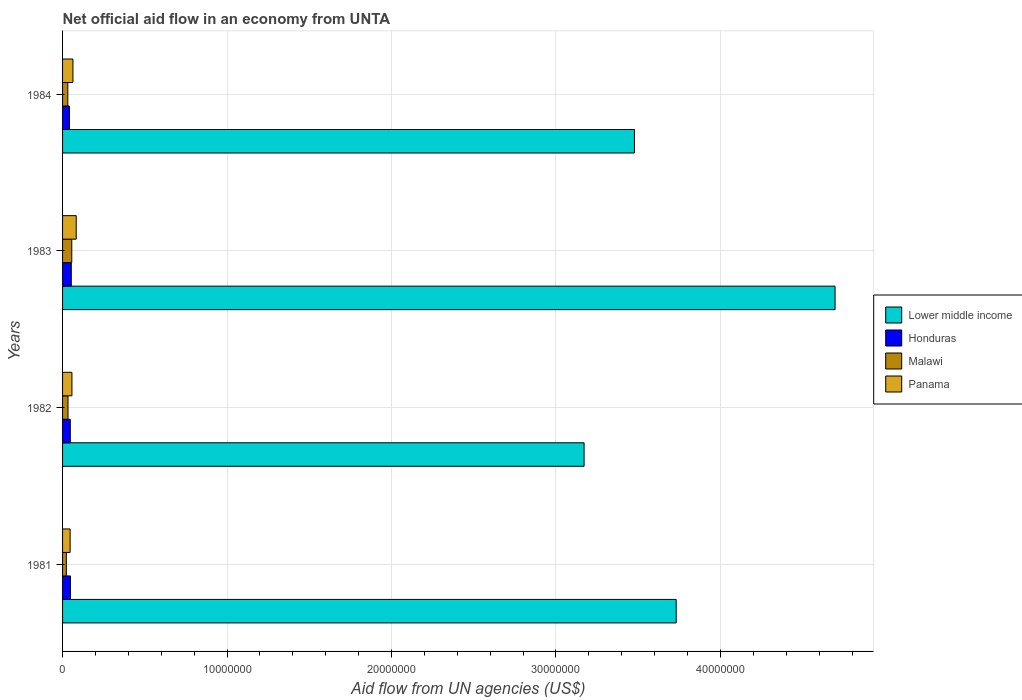How many different coloured bars are there?
Your answer should be compact. 4. Are the number of bars per tick equal to the number of legend labels?
Offer a very short reply. Yes. Are the number of bars on each tick of the Y-axis equal?
Offer a terse response. Yes. Across all years, what is the maximum net official aid flow in Honduras?
Offer a terse response. 5.30e+05. Across all years, what is the minimum net official aid flow in Malawi?
Provide a short and direct response. 2.30e+05. In which year was the net official aid flow in Honduras minimum?
Your answer should be very brief. 1984. What is the total net official aid flow in Honduras in the graph?
Offer a very short reply. 1.90e+06. What is the difference between the net official aid flow in Lower middle income in 1983 and that in 1984?
Keep it short and to the point. 1.22e+07. What is the average net official aid flow in Lower middle income per year?
Make the answer very short. 3.77e+07. In the year 1983, what is the difference between the net official aid flow in Honduras and net official aid flow in Malawi?
Ensure brevity in your answer.  -3.00e+04. What is the ratio of the net official aid flow in Panama in 1982 to that in 1984?
Your answer should be very brief. 0.9. Is the difference between the net official aid flow in Honduras in 1983 and 1984 greater than the difference between the net official aid flow in Malawi in 1983 and 1984?
Give a very brief answer. No. What is the difference between the highest and the second highest net official aid flow in Lower middle income?
Make the answer very short. 9.66e+06. What is the difference between the highest and the lowest net official aid flow in Lower middle income?
Provide a short and direct response. 1.53e+07. In how many years, is the net official aid flow in Honduras greater than the average net official aid flow in Honduras taken over all years?
Your answer should be very brief. 2. Is the sum of the net official aid flow in Lower middle income in 1982 and 1983 greater than the maximum net official aid flow in Malawi across all years?
Offer a very short reply. Yes. What does the 2nd bar from the top in 1983 represents?
Keep it short and to the point. Malawi. What does the 1st bar from the bottom in 1984 represents?
Provide a short and direct response. Lower middle income. Is it the case that in every year, the sum of the net official aid flow in Lower middle income and net official aid flow in Honduras is greater than the net official aid flow in Malawi?
Your answer should be compact. Yes. How many years are there in the graph?
Offer a very short reply. 4. What is the difference between two consecutive major ticks on the X-axis?
Provide a succinct answer. 1.00e+07. Are the values on the major ticks of X-axis written in scientific E-notation?
Ensure brevity in your answer.  No. Where does the legend appear in the graph?
Provide a short and direct response. Center right. How are the legend labels stacked?
Ensure brevity in your answer.  Vertical. What is the title of the graph?
Make the answer very short. Net official aid flow in an economy from UNTA. Does "Switzerland" appear as one of the legend labels in the graph?
Your response must be concise. No. What is the label or title of the X-axis?
Your response must be concise. Aid flow from UN agencies (US$). What is the Aid flow from UN agencies (US$) of Lower middle income in 1981?
Give a very brief answer. 3.73e+07. What is the Aid flow from UN agencies (US$) of Panama in 1981?
Provide a succinct answer. 4.60e+05. What is the Aid flow from UN agencies (US$) in Lower middle income in 1982?
Provide a succinct answer. 3.17e+07. What is the Aid flow from UN agencies (US$) of Honduras in 1982?
Provide a succinct answer. 4.70e+05. What is the Aid flow from UN agencies (US$) in Malawi in 1982?
Offer a very short reply. 3.30e+05. What is the Aid flow from UN agencies (US$) in Panama in 1982?
Make the answer very short. 5.70e+05. What is the Aid flow from UN agencies (US$) of Lower middle income in 1983?
Give a very brief answer. 4.70e+07. What is the Aid flow from UN agencies (US$) of Honduras in 1983?
Give a very brief answer. 5.30e+05. What is the Aid flow from UN agencies (US$) of Malawi in 1983?
Ensure brevity in your answer.  5.60e+05. What is the Aid flow from UN agencies (US$) of Panama in 1983?
Your answer should be very brief. 8.30e+05. What is the Aid flow from UN agencies (US$) in Lower middle income in 1984?
Make the answer very short. 3.48e+07. What is the Aid flow from UN agencies (US$) in Honduras in 1984?
Your answer should be compact. 4.20e+05. What is the Aid flow from UN agencies (US$) of Panama in 1984?
Make the answer very short. 6.30e+05. Across all years, what is the maximum Aid flow from UN agencies (US$) of Lower middle income?
Your answer should be compact. 4.70e+07. Across all years, what is the maximum Aid flow from UN agencies (US$) of Honduras?
Offer a terse response. 5.30e+05. Across all years, what is the maximum Aid flow from UN agencies (US$) of Malawi?
Your answer should be very brief. 5.60e+05. Across all years, what is the maximum Aid flow from UN agencies (US$) of Panama?
Your answer should be compact. 8.30e+05. Across all years, what is the minimum Aid flow from UN agencies (US$) in Lower middle income?
Provide a succinct answer. 3.17e+07. Across all years, what is the minimum Aid flow from UN agencies (US$) in Honduras?
Provide a short and direct response. 4.20e+05. Across all years, what is the minimum Aid flow from UN agencies (US$) in Malawi?
Ensure brevity in your answer.  2.30e+05. What is the total Aid flow from UN agencies (US$) in Lower middle income in the graph?
Ensure brevity in your answer.  1.51e+08. What is the total Aid flow from UN agencies (US$) of Honduras in the graph?
Give a very brief answer. 1.90e+06. What is the total Aid flow from UN agencies (US$) of Malawi in the graph?
Provide a short and direct response. 1.44e+06. What is the total Aid flow from UN agencies (US$) of Panama in the graph?
Give a very brief answer. 2.49e+06. What is the difference between the Aid flow from UN agencies (US$) in Lower middle income in 1981 and that in 1982?
Offer a very short reply. 5.60e+06. What is the difference between the Aid flow from UN agencies (US$) in Honduras in 1981 and that in 1982?
Offer a very short reply. 10000. What is the difference between the Aid flow from UN agencies (US$) in Lower middle income in 1981 and that in 1983?
Keep it short and to the point. -9.66e+06. What is the difference between the Aid flow from UN agencies (US$) in Honduras in 1981 and that in 1983?
Your answer should be compact. -5.00e+04. What is the difference between the Aid flow from UN agencies (US$) in Malawi in 1981 and that in 1983?
Your answer should be very brief. -3.30e+05. What is the difference between the Aid flow from UN agencies (US$) in Panama in 1981 and that in 1983?
Keep it short and to the point. -3.70e+05. What is the difference between the Aid flow from UN agencies (US$) in Lower middle income in 1981 and that in 1984?
Your response must be concise. 2.54e+06. What is the difference between the Aid flow from UN agencies (US$) of Honduras in 1981 and that in 1984?
Your answer should be compact. 6.00e+04. What is the difference between the Aid flow from UN agencies (US$) in Panama in 1981 and that in 1984?
Your answer should be compact. -1.70e+05. What is the difference between the Aid flow from UN agencies (US$) of Lower middle income in 1982 and that in 1983?
Your response must be concise. -1.53e+07. What is the difference between the Aid flow from UN agencies (US$) in Honduras in 1982 and that in 1983?
Provide a short and direct response. -6.00e+04. What is the difference between the Aid flow from UN agencies (US$) in Lower middle income in 1982 and that in 1984?
Your response must be concise. -3.06e+06. What is the difference between the Aid flow from UN agencies (US$) in Lower middle income in 1983 and that in 1984?
Your answer should be very brief. 1.22e+07. What is the difference between the Aid flow from UN agencies (US$) of Honduras in 1983 and that in 1984?
Provide a short and direct response. 1.10e+05. What is the difference between the Aid flow from UN agencies (US$) of Malawi in 1983 and that in 1984?
Give a very brief answer. 2.40e+05. What is the difference between the Aid flow from UN agencies (US$) of Panama in 1983 and that in 1984?
Your answer should be compact. 2.00e+05. What is the difference between the Aid flow from UN agencies (US$) in Lower middle income in 1981 and the Aid flow from UN agencies (US$) in Honduras in 1982?
Offer a very short reply. 3.68e+07. What is the difference between the Aid flow from UN agencies (US$) of Lower middle income in 1981 and the Aid flow from UN agencies (US$) of Malawi in 1982?
Your answer should be very brief. 3.70e+07. What is the difference between the Aid flow from UN agencies (US$) in Lower middle income in 1981 and the Aid flow from UN agencies (US$) in Panama in 1982?
Offer a terse response. 3.67e+07. What is the difference between the Aid flow from UN agencies (US$) of Lower middle income in 1981 and the Aid flow from UN agencies (US$) of Honduras in 1983?
Your answer should be very brief. 3.68e+07. What is the difference between the Aid flow from UN agencies (US$) in Lower middle income in 1981 and the Aid flow from UN agencies (US$) in Malawi in 1983?
Provide a short and direct response. 3.68e+07. What is the difference between the Aid flow from UN agencies (US$) of Lower middle income in 1981 and the Aid flow from UN agencies (US$) of Panama in 1983?
Give a very brief answer. 3.65e+07. What is the difference between the Aid flow from UN agencies (US$) of Honduras in 1981 and the Aid flow from UN agencies (US$) of Panama in 1983?
Give a very brief answer. -3.50e+05. What is the difference between the Aid flow from UN agencies (US$) of Malawi in 1981 and the Aid flow from UN agencies (US$) of Panama in 1983?
Provide a short and direct response. -6.00e+05. What is the difference between the Aid flow from UN agencies (US$) in Lower middle income in 1981 and the Aid flow from UN agencies (US$) in Honduras in 1984?
Provide a short and direct response. 3.69e+07. What is the difference between the Aid flow from UN agencies (US$) in Lower middle income in 1981 and the Aid flow from UN agencies (US$) in Malawi in 1984?
Your answer should be very brief. 3.70e+07. What is the difference between the Aid flow from UN agencies (US$) in Lower middle income in 1981 and the Aid flow from UN agencies (US$) in Panama in 1984?
Keep it short and to the point. 3.67e+07. What is the difference between the Aid flow from UN agencies (US$) in Honduras in 1981 and the Aid flow from UN agencies (US$) in Panama in 1984?
Offer a very short reply. -1.50e+05. What is the difference between the Aid flow from UN agencies (US$) of Malawi in 1981 and the Aid flow from UN agencies (US$) of Panama in 1984?
Keep it short and to the point. -4.00e+05. What is the difference between the Aid flow from UN agencies (US$) in Lower middle income in 1982 and the Aid flow from UN agencies (US$) in Honduras in 1983?
Your answer should be very brief. 3.12e+07. What is the difference between the Aid flow from UN agencies (US$) in Lower middle income in 1982 and the Aid flow from UN agencies (US$) in Malawi in 1983?
Offer a terse response. 3.12e+07. What is the difference between the Aid flow from UN agencies (US$) of Lower middle income in 1982 and the Aid flow from UN agencies (US$) of Panama in 1983?
Ensure brevity in your answer.  3.09e+07. What is the difference between the Aid flow from UN agencies (US$) in Honduras in 1982 and the Aid flow from UN agencies (US$) in Panama in 1983?
Offer a terse response. -3.60e+05. What is the difference between the Aid flow from UN agencies (US$) in Malawi in 1982 and the Aid flow from UN agencies (US$) in Panama in 1983?
Offer a terse response. -5.00e+05. What is the difference between the Aid flow from UN agencies (US$) of Lower middle income in 1982 and the Aid flow from UN agencies (US$) of Honduras in 1984?
Your answer should be very brief. 3.13e+07. What is the difference between the Aid flow from UN agencies (US$) in Lower middle income in 1982 and the Aid flow from UN agencies (US$) in Malawi in 1984?
Keep it short and to the point. 3.14e+07. What is the difference between the Aid flow from UN agencies (US$) in Lower middle income in 1982 and the Aid flow from UN agencies (US$) in Panama in 1984?
Provide a succinct answer. 3.11e+07. What is the difference between the Aid flow from UN agencies (US$) in Malawi in 1982 and the Aid flow from UN agencies (US$) in Panama in 1984?
Your response must be concise. -3.00e+05. What is the difference between the Aid flow from UN agencies (US$) of Lower middle income in 1983 and the Aid flow from UN agencies (US$) of Honduras in 1984?
Keep it short and to the point. 4.66e+07. What is the difference between the Aid flow from UN agencies (US$) of Lower middle income in 1983 and the Aid flow from UN agencies (US$) of Malawi in 1984?
Offer a terse response. 4.66e+07. What is the difference between the Aid flow from UN agencies (US$) in Lower middle income in 1983 and the Aid flow from UN agencies (US$) in Panama in 1984?
Your response must be concise. 4.63e+07. What is the difference between the Aid flow from UN agencies (US$) in Honduras in 1983 and the Aid flow from UN agencies (US$) in Malawi in 1984?
Your answer should be compact. 2.10e+05. What is the average Aid flow from UN agencies (US$) of Lower middle income per year?
Give a very brief answer. 3.77e+07. What is the average Aid flow from UN agencies (US$) of Honduras per year?
Your response must be concise. 4.75e+05. What is the average Aid flow from UN agencies (US$) of Malawi per year?
Your response must be concise. 3.60e+05. What is the average Aid flow from UN agencies (US$) in Panama per year?
Your answer should be very brief. 6.22e+05. In the year 1981, what is the difference between the Aid flow from UN agencies (US$) in Lower middle income and Aid flow from UN agencies (US$) in Honduras?
Give a very brief answer. 3.68e+07. In the year 1981, what is the difference between the Aid flow from UN agencies (US$) in Lower middle income and Aid flow from UN agencies (US$) in Malawi?
Ensure brevity in your answer.  3.71e+07. In the year 1981, what is the difference between the Aid flow from UN agencies (US$) in Lower middle income and Aid flow from UN agencies (US$) in Panama?
Provide a short and direct response. 3.68e+07. In the year 1981, what is the difference between the Aid flow from UN agencies (US$) in Honduras and Aid flow from UN agencies (US$) in Malawi?
Your response must be concise. 2.50e+05. In the year 1981, what is the difference between the Aid flow from UN agencies (US$) of Honduras and Aid flow from UN agencies (US$) of Panama?
Ensure brevity in your answer.  2.00e+04. In the year 1982, what is the difference between the Aid flow from UN agencies (US$) in Lower middle income and Aid flow from UN agencies (US$) in Honduras?
Keep it short and to the point. 3.12e+07. In the year 1982, what is the difference between the Aid flow from UN agencies (US$) of Lower middle income and Aid flow from UN agencies (US$) of Malawi?
Make the answer very short. 3.14e+07. In the year 1982, what is the difference between the Aid flow from UN agencies (US$) of Lower middle income and Aid flow from UN agencies (US$) of Panama?
Your answer should be compact. 3.11e+07. In the year 1982, what is the difference between the Aid flow from UN agencies (US$) of Honduras and Aid flow from UN agencies (US$) of Malawi?
Keep it short and to the point. 1.40e+05. In the year 1982, what is the difference between the Aid flow from UN agencies (US$) of Honduras and Aid flow from UN agencies (US$) of Panama?
Your answer should be very brief. -1.00e+05. In the year 1983, what is the difference between the Aid flow from UN agencies (US$) of Lower middle income and Aid flow from UN agencies (US$) of Honduras?
Keep it short and to the point. 4.64e+07. In the year 1983, what is the difference between the Aid flow from UN agencies (US$) in Lower middle income and Aid flow from UN agencies (US$) in Malawi?
Offer a terse response. 4.64e+07. In the year 1983, what is the difference between the Aid flow from UN agencies (US$) of Lower middle income and Aid flow from UN agencies (US$) of Panama?
Offer a very short reply. 4.61e+07. In the year 1983, what is the difference between the Aid flow from UN agencies (US$) of Honduras and Aid flow from UN agencies (US$) of Malawi?
Your response must be concise. -3.00e+04. In the year 1984, what is the difference between the Aid flow from UN agencies (US$) in Lower middle income and Aid flow from UN agencies (US$) in Honduras?
Offer a terse response. 3.44e+07. In the year 1984, what is the difference between the Aid flow from UN agencies (US$) in Lower middle income and Aid flow from UN agencies (US$) in Malawi?
Provide a succinct answer. 3.44e+07. In the year 1984, what is the difference between the Aid flow from UN agencies (US$) in Lower middle income and Aid flow from UN agencies (US$) in Panama?
Your answer should be very brief. 3.41e+07. In the year 1984, what is the difference between the Aid flow from UN agencies (US$) of Honduras and Aid flow from UN agencies (US$) of Malawi?
Your response must be concise. 1.00e+05. In the year 1984, what is the difference between the Aid flow from UN agencies (US$) of Honduras and Aid flow from UN agencies (US$) of Panama?
Your response must be concise. -2.10e+05. In the year 1984, what is the difference between the Aid flow from UN agencies (US$) in Malawi and Aid flow from UN agencies (US$) in Panama?
Your answer should be very brief. -3.10e+05. What is the ratio of the Aid flow from UN agencies (US$) in Lower middle income in 1981 to that in 1982?
Provide a short and direct response. 1.18. What is the ratio of the Aid flow from UN agencies (US$) in Honduras in 1981 to that in 1982?
Ensure brevity in your answer.  1.02. What is the ratio of the Aid flow from UN agencies (US$) of Malawi in 1981 to that in 1982?
Make the answer very short. 0.7. What is the ratio of the Aid flow from UN agencies (US$) in Panama in 1981 to that in 1982?
Offer a very short reply. 0.81. What is the ratio of the Aid flow from UN agencies (US$) of Lower middle income in 1981 to that in 1983?
Your answer should be compact. 0.79. What is the ratio of the Aid flow from UN agencies (US$) of Honduras in 1981 to that in 1983?
Provide a succinct answer. 0.91. What is the ratio of the Aid flow from UN agencies (US$) of Malawi in 1981 to that in 1983?
Keep it short and to the point. 0.41. What is the ratio of the Aid flow from UN agencies (US$) in Panama in 1981 to that in 1983?
Your response must be concise. 0.55. What is the ratio of the Aid flow from UN agencies (US$) in Lower middle income in 1981 to that in 1984?
Your answer should be compact. 1.07. What is the ratio of the Aid flow from UN agencies (US$) of Honduras in 1981 to that in 1984?
Your answer should be very brief. 1.14. What is the ratio of the Aid flow from UN agencies (US$) in Malawi in 1981 to that in 1984?
Offer a terse response. 0.72. What is the ratio of the Aid flow from UN agencies (US$) of Panama in 1981 to that in 1984?
Offer a very short reply. 0.73. What is the ratio of the Aid flow from UN agencies (US$) in Lower middle income in 1982 to that in 1983?
Provide a succinct answer. 0.68. What is the ratio of the Aid flow from UN agencies (US$) in Honduras in 1982 to that in 1983?
Offer a very short reply. 0.89. What is the ratio of the Aid flow from UN agencies (US$) of Malawi in 1982 to that in 1983?
Provide a succinct answer. 0.59. What is the ratio of the Aid flow from UN agencies (US$) of Panama in 1982 to that in 1983?
Ensure brevity in your answer.  0.69. What is the ratio of the Aid flow from UN agencies (US$) of Lower middle income in 1982 to that in 1984?
Ensure brevity in your answer.  0.91. What is the ratio of the Aid flow from UN agencies (US$) of Honduras in 1982 to that in 1984?
Your answer should be compact. 1.12. What is the ratio of the Aid flow from UN agencies (US$) in Malawi in 1982 to that in 1984?
Give a very brief answer. 1.03. What is the ratio of the Aid flow from UN agencies (US$) in Panama in 1982 to that in 1984?
Your response must be concise. 0.9. What is the ratio of the Aid flow from UN agencies (US$) of Lower middle income in 1983 to that in 1984?
Keep it short and to the point. 1.35. What is the ratio of the Aid flow from UN agencies (US$) of Honduras in 1983 to that in 1984?
Give a very brief answer. 1.26. What is the ratio of the Aid flow from UN agencies (US$) of Panama in 1983 to that in 1984?
Keep it short and to the point. 1.32. What is the difference between the highest and the second highest Aid flow from UN agencies (US$) of Lower middle income?
Keep it short and to the point. 9.66e+06. What is the difference between the highest and the second highest Aid flow from UN agencies (US$) of Malawi?
Your answer should be compact. 2.30e+05. What is the difference between the highest and the lowest Aid flow from UN agencies (US$) in Lower middle income?
Offer a terse response. 1.53e+07. What is the difference between the highest and the lowest Aid flow from UN agencies (US$) of Honduras?
Provide a succinct answer. 1.10e+05. What is the difference between the highest and the lowest Aid flow from UN agencies (US$) in Malawi?
Your answer should be compact. 3.30e+05. What is the difference between the highest and the lowest Aid flow from UN agencies (US$) in Panama?
Your answer should be compact. 3.70e+05. 